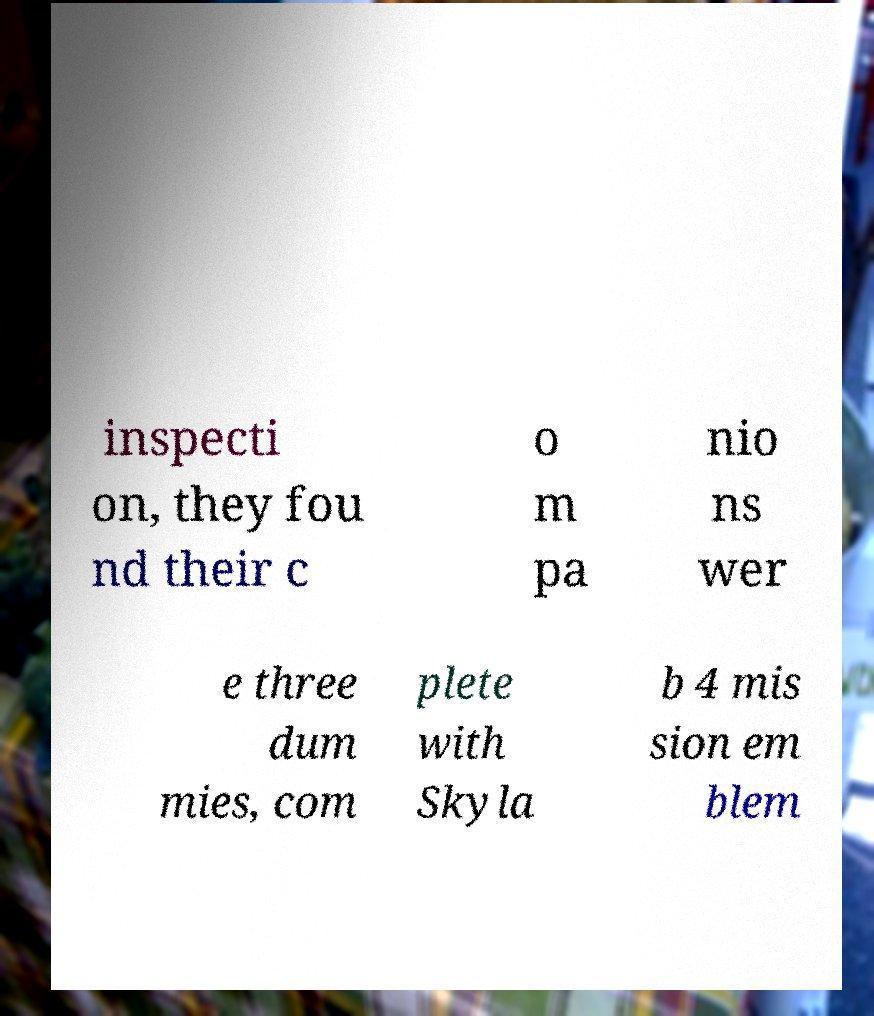I need the written content from this picture converted into text. Can you do that? inspecti on, they fou nd their c o m pa nio ns wer e three dum mies, com plete with Skyla b 4 mis sion em blem 